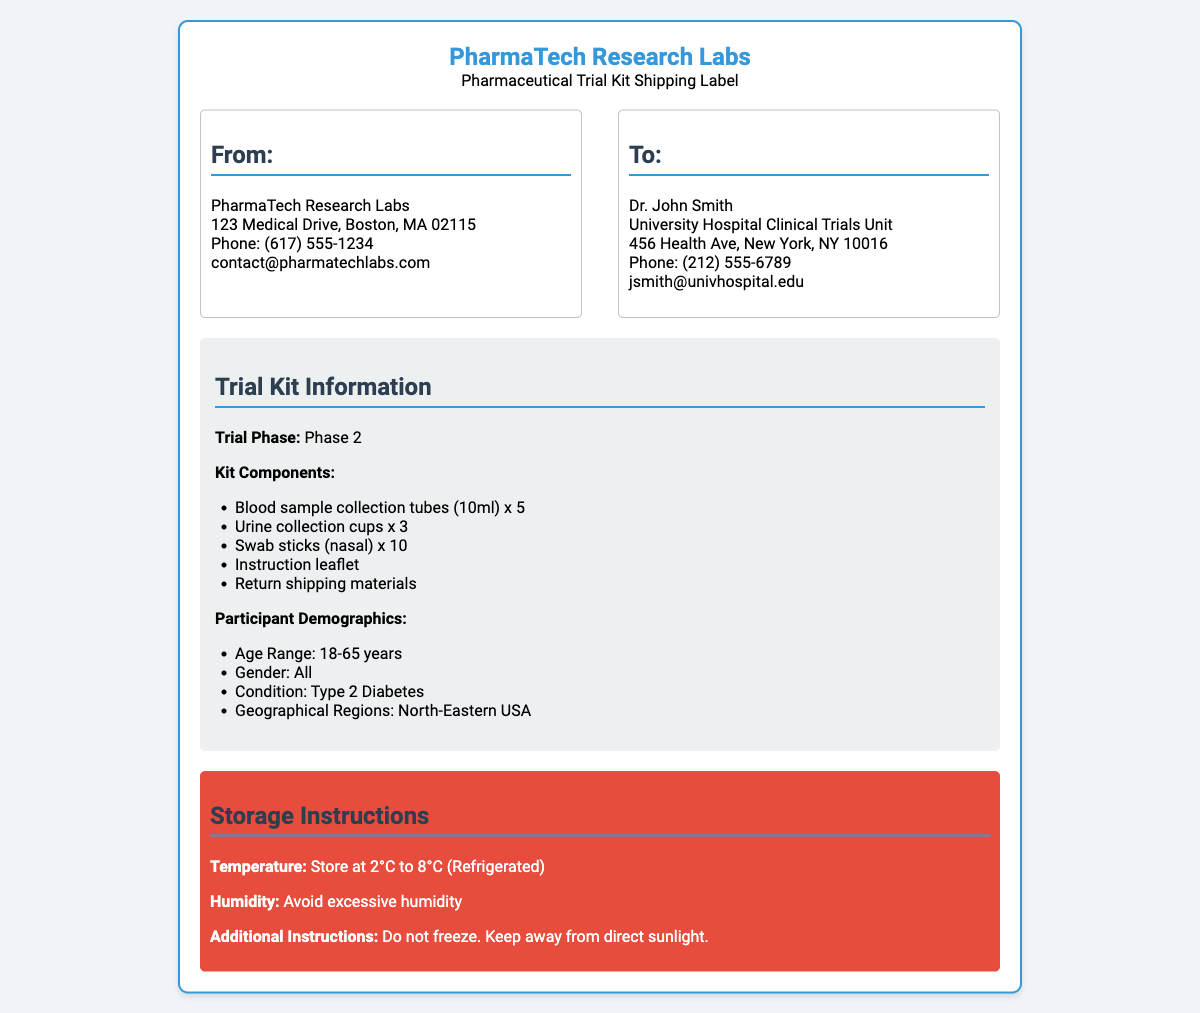What is the name of the shipping lab? The name of the shipping lab is located at the top of the document as the sender's name.
Answer: PharmaTech Research Labs Who is the recipient of the shipping label? The recipient's name is listed in the "To:" section of the addresses.
Answer: Dr. John Smith What are the storage temperature instructions? The storage temperature instructions are specified in the storage section.
Answer: 2°C to 8°C (Refrigerated) How many blood sample collection tubes are included in the kit? The number of blood sample collection tubes is found in the kit components list.
Answer: 5 What condition are the trial participants required to have? The condition for trial participants is stated in the participant demographics section.
Answer: Type 2 Diabetes What is the geographical region for participant recruitment? The geographical region relevant for the trial is mentioned in the demographics.
Answer: North-Eastern USA How many urine collection cups are supplied in this trial kit? The number of urine collection cups can be found in the kit components list.
Answer: 3 What is the kit phase? The trial phase of the kit is mentioned prominently in the document.
Answer: Phase 2 What type of swab sticks are included in the kit? The type of swab sticks is detailed in the kit components section.
Answer: Nasal 